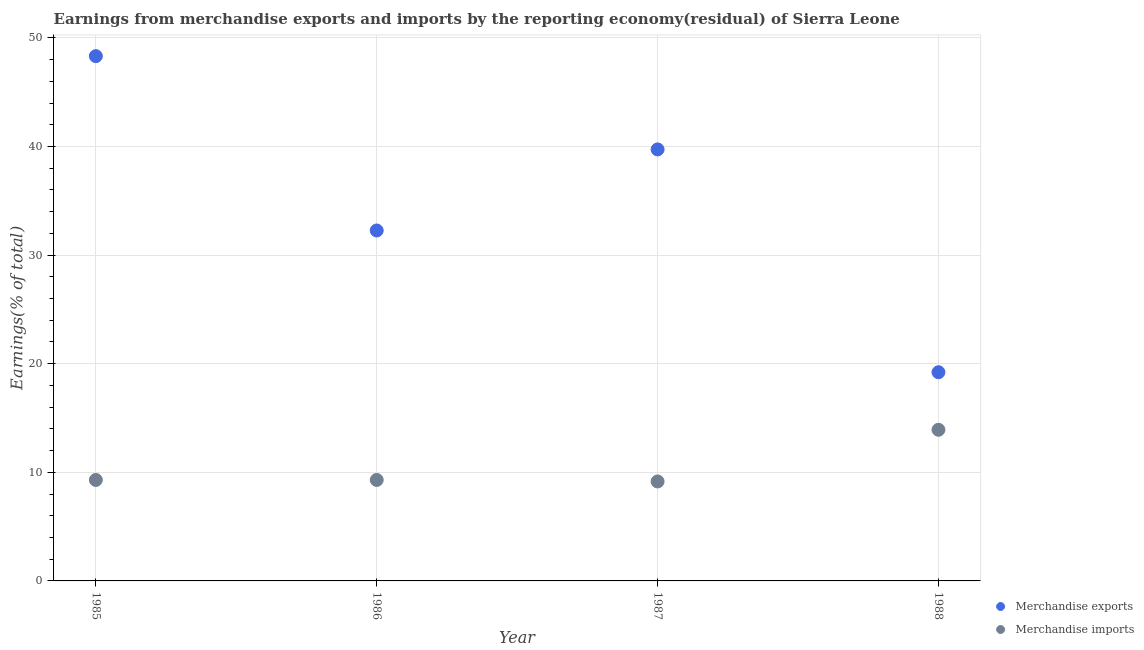Is the number of dotlines equal to the number of legend labels?
Your answer should be compact. Yes. What is the earnings from merchandise exports in 1987?
Your answer should be compact. 39.73. Across all years, what is the maximum earnings from merchandise imports?
Keep it short and to the point. 13.92. Across all years, what is the minimum earnings from merchandise exports?
Provide a succinct answer. 19.22. What is the total earnings from merchandise exports in the graph?
Your response must be concise. 139.54. What is the difference between the earnings from merchandise exports in 1985 and that in 1987?
Give a very brief answer. 8.59. What is the difference between the earnings from merchandise imports in 1987 and the earnings from merchandise exports in 1986?
Offer a very short reply. -23.11. What is the average earnings from merchandise imports per year?
Your answer should be very brief. 10.42. In the year 1985, what is the difference between the earnings from merchandise imports and earnings from merchandise exports?
Keep it short and to the point. -39.02. What is the ratio of the earnings from merchandise exports in 1985 to that in 1986?
Your response must be concise. 1.5. Is the earnings from merchandise exports in 1985 less than that in 1986?
Ensure brevity in your answer.  No. Is the difference between the earnings from merchandise exports in 1985 and 1988 greater than the difference between the earnings from merchandise imports in 1985 and 1988?
Offer a very short reply. Yes. What is the difference between the highest and the second highest earnings from merchandise exports?
Give a very brief answer. 8.59. What is the difference between the highest and the lowest earnings from merchandise imports?
Provide a short and direct response. 4.76. Is the sum of the earnings from merchandise exports in 1985 and 1988 greater than the maximum earnings from merchandise imports across all years?
Your answer should be compact. Yes. Is the earnings from merchandise exports strictly less than the earnings from merchandise imports over the years?
Offer a terse response. No. How many years are there in the graph?
Offer a terse response. 4. Where does the legend appear in the graph?
Your answer should be compact. Bottom right. What is the title of the graph?
Your answer should be very brief. Earnings from merchandise exports and imports by the reporting economy(residual) of Sierra Leone. What is the label or title of the Y-axis?
Make the answer very short. Earnings(% of total). What is the Earnings(% of total) in Merchandise exports in 1985?
Provide a succinct answer. 48.32. What is the Earnings(% of total) in Merchandise imports in 1985?
Your answer should be compact. 9.3. What is the Earnings(% of total) in Merchandise exports in 1986?
Provide a short and direct response. 32.27. What is the Earnings(% of total) of Merchandise imports in 1986?
Provide a short and direct response. 9.3. What is the Earnings(% of total) of Merchandise exports in 1987?
Provide a succinct answer. 39.73. What is the Earnings(% of total) in Merchandise imports in 1987?
Your answer should be very brief. 9.16. What is the Earnings(% of total) of Merchandise exports in 1988?
Your answer should be very brief. 19.22. What is the Earnings(% of total) in Merchandise imports in 1988?
Ensure brevity in your answer.  13.92. Across all years, what is the maximum Earnings(% of total) in Merchandise exports?
Keep it short and to the point. 48.32. Across all years, what is the maximum Earnings(% of total) in Merchandise imports?
Ensure brevity in your answer.  13.92. Across all years, what is the minimum Earnings(% of total) in Merchandise exports?
Your response must be concise. 19.22. Across all years, what is the minimum Earnings(% of total) of Merchandise imports?
Your response must be concise. 9.16. What is the total Earnings(% of total) of Merchandise exports in the graph?
Your answer should be very brief. 139.54. What is the total Earnings(% of total) of Merchandise imports in the graph?
Make the answer very short. 41.67. What is the difference between the Earnings(% of total) in Merchandise exports in 1985 and that in 1986?
Provide a succinct answer. 16.05. What is the difference between the Earnings(% of total) of Merchandise imports in 1985 and that in 1986?
Offer a very short reply. 0. What is the difference between the Earnings(% of total) in Merchandise exports in 1985 and that in 1987?
Give a very brief answer. 8.59. What is the difference between the Earnings(% of total) in Merchandise imports in 1985 and that in 1987?
Your answer should be compact. 0.14. What is the difference between the Earnings(% of total) in Merchandise exports in 1985 and that in 1988?
Keep it short and to the point. 29.1. What is the difference between the Earnings(% of total) of Merchandise imports in 1985 and that in 1988?
Keep it short and to the point. -4.62. What is the difference between the Earnings(% of total) in Merchandise exports in 1986 and that in 1987?
Make the answer very short. -7.47. What is the difference between the Earnings(% of total) in Merchandise imports in 1986 and that in 1987?
Your answer should be compact. 0.14. What is the difference between the Earnings(% of total) of Merchandise exports in 1986 and that in 1988?
Offer a terse response. 13.05. What is the difference between the Earnings(% of total) of Merchandise imports in 1986 and that in 1988?
Offer a very short reply. -4.62. What is the difference between the Earnings(% of total) in Merchandise exports in 1987 and that in 1988?
Ensure brevity in your answer.  20.52. What is the difference between the Earnings(% of total) in Merchandise imports in 1987 and that in 1988?
Your answer should be very brief. -4.76. What is the difference between the Earnings(% of total) of Merchandise exports in 1985 and the Earnings(% of total) of Merchandise imports in 1986?
Offer a terse response. 39.02. What is the difference between the Earnings(% of total) of Merchandise exports in 1985 and the Earnings(% of total) of Merchandise imports in 1987?
Ensure brevity in your answer.  39.16. What is the difference between the Earnings(% of total) in Merchandise exports in 1985 and the Earnings(% of total) in Merchandise imports in 1988?
Offer a very short reply. 34.4. What is the difference between the Earnings(% of total) in Merchandise exports in 1986 and the Earnings(% of total) in Merchandise imports in 1987?
Offer a very short reply. 23.11. What is the difference between the Earnings(% of total) in Merchandise exports in 1986 and the Earnings(% of total) in Merchandise imports in 1988?
Provide a succinct answer. 18.35. What is the difference between the Earnings(% of total) of Merchandise exports in 1987 and the Earnings(% of total) of Merchandise imports in 1988?
Make the answer very short. 25.82. What is the average Earnings(% of total) of Merchandise exports per year?
Provide a short and direct response. 34.88. What is the average Earnings(% of total) of Merchandise imports per year?
Make the answer very short. 10.42. In the year 1985, what is the difference between the Earnings(% of total) of Merchandise exports and Earnings(% of total) of Merchandise imports?
Make the answer very short. 39.02. In the year 1986, what is the difference between the Earnings(% of total) in Merchandise exports and Earnings(% of total) in Merchandise imports?
Keep it short and to the point. 22.97. In the year 1987, what is the difference between the Earnings(% of total) in Merchandise exports and Earnings(% of total) in Merchandise imports?
Offer a very short reply. 30.57. What is the ratio of the Earnings(% of total) of Merchandise exports in 1985 to that in 1986?
Ensure brevity in your answer.  1.5. What is the ratio of the Earnings(% of total) of Merchandise exports in 1985 to that in 1987?
Your answer should be very brief. 1.22. What is the ratio of the Earnings(% of total) of Merchandise exports in 1985 to that in 1988?
Provide a short and direct response. 2.51. What is the ratio of the Earnings(% of total) in Merchandise imports in 1985 to that in 1988?
Give a very brief answer. 0.67. What is the ratio of the Earnings(% of total) in Merchandise exports in 1986 to that in 1987?
Provide a succinct answer. 0.81. What is the ratio of the Earnings(% of total) of Merchandise exports in 1986 to that in 1988?
Offer a terse response. 1.68. What is the ratio of the Earnings(% of total) of Merchandise imports in 1986 to that in 1988?
Your response must be concise. 0.67. What is the ratio of the Earnings(% of total) in Merchandise exports in 1987 to that in 1988?
Give a very brief answer. 2.07. What is the ratio of the Earnings(% of total) of Merchandise imports in 1987 to that in 1988?
Keep it short and to the point. 0.66. What is the difference between the highest and the second highest Earnings(% of total) of Merchandise exports?
Offer a very short reply. 8.59. What is the difference between the highest and the second highest Earnings(% of total) in Merchandise imports?
Your response must be concise. 4.62. What is the difference between the highest and the lowest Earnings(% of total) of Merchandise exports?
Your answer should be very brief. 29.1. What is the difference between the highest and the lowest Earnings(% of total) of Merchandise imports?
Offer a very short reply. 4.76. 